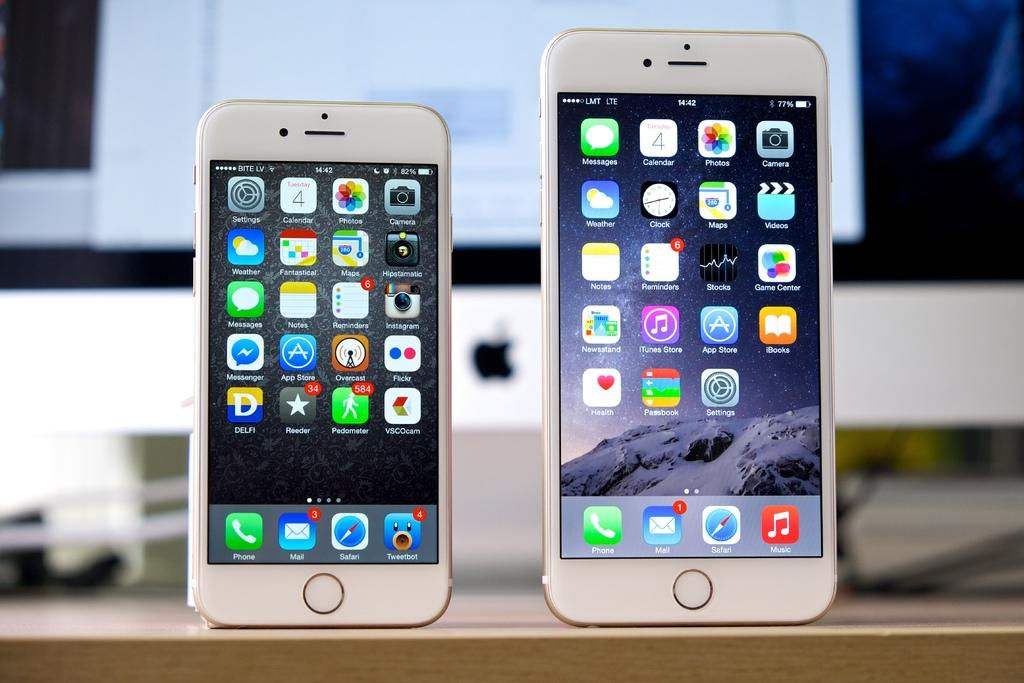<image>
Render a clear and concise summary of the photo. Two iPhones with the apps phone, mail, safari, music and tweetbot at the bottom. 